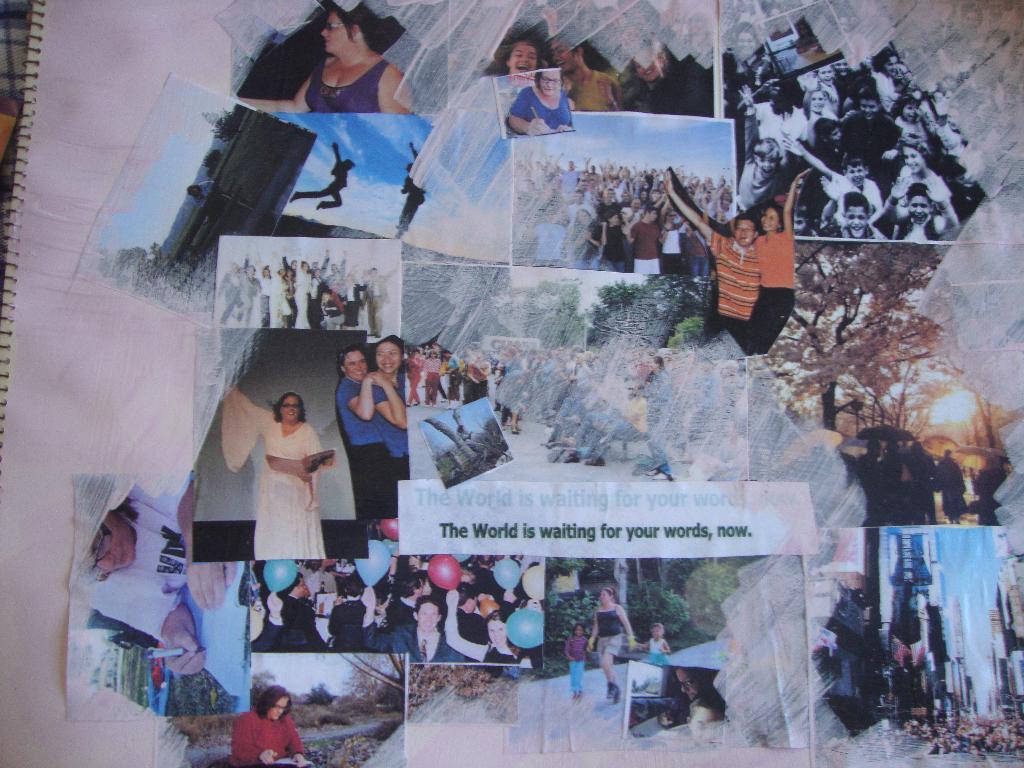What is waiting for your words?
Give a very brief answer. The world. What does the writing in the middle read?
Give a very brief answer. The world is waiting for your words, now. 